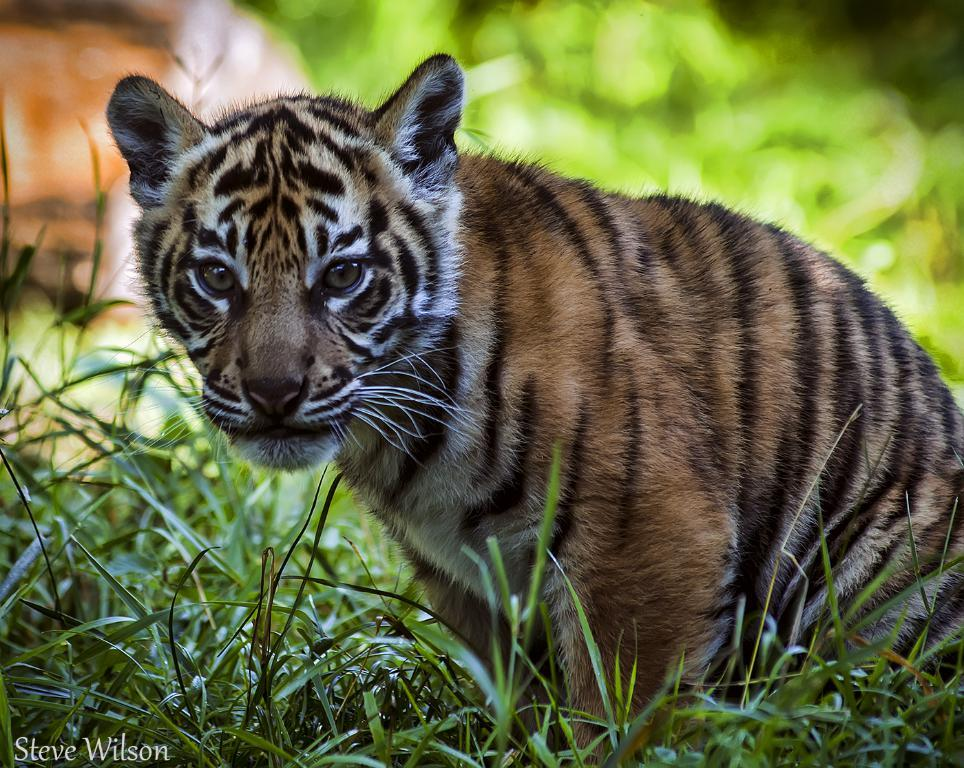What animal is in the center of the image? There is a tiger in the center of the image. How would you describe the background of the image? The background of the image is blurry. What type of terrain is visible at the bottom of the image? There is grass at the bottom of the image. Can you identify any text in the image? Yes, there is some text visible in the image. What type of thunder can be heard in the image? There is no sound, including thunder, present in the image. 